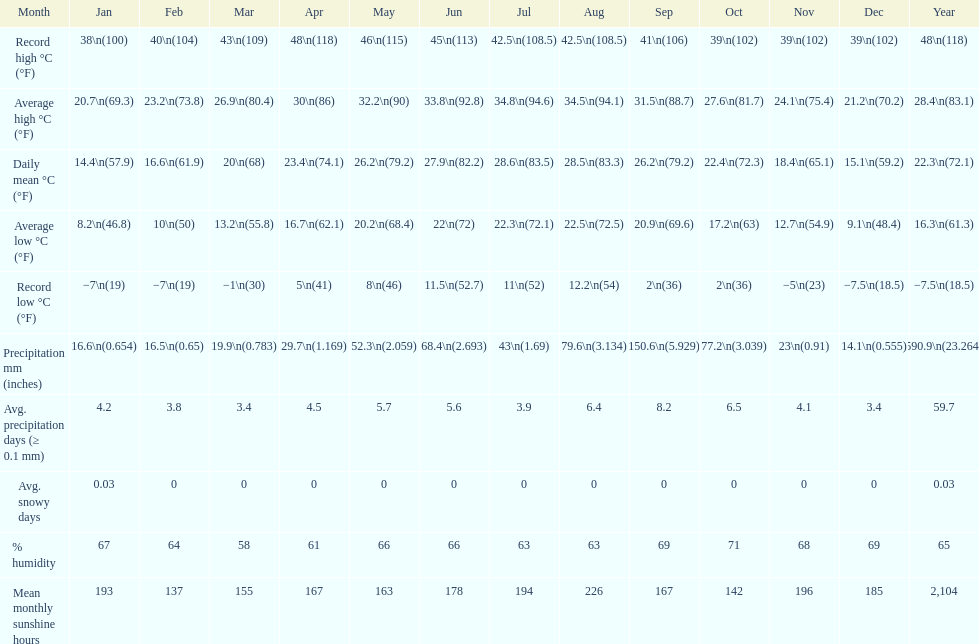Did march or april have more precipitation? April. Could you help me parse every detail presented in this table? {'header': ['Month', 'Jan', 'Feb', 'Mar', 'Apr', 'May', 'Jun', 'Jul', 'Aug', 'Sep', 'Oct', 'Nov', 'Dec', 'Year'], 'rows': [['Record high °C (°F)', '38\\n(100)', '40\\n(104)', '43\\n(109)', '48\\n(118)', '46\\n(115)', '45\\n(113)', '42.5\\n(108.5)', '42.5\\n(108.5)', '41\\n(106)', '39\\n(102)', '39\\n(102)', '39\\n(102)', '48\\n(118)'], ['Average high °C (°F)', '20.7\\n(69.3)', '23.2\\n(73.8)', '26.9\\n(80.4)', '30\\n(86)', '32.2\\n(90)', '33.8\\n(92.8)', '34.8\\n(94.6)', '34.5\\n(94.1)', '31.5\\n(88.7)', '27.6\\n(81.7)', '24.1\\n(75.4)', '21.2\\n(70.2)', '28.4\\n(83.1)'], ['Daily mean °C (°F)', '14.4\\n(57.9)', '16.6\\n(61.9)', '20\\n(68)', '23.4\\n(74.1)', '26.2\\n(79.2)', '27.9\\n(82.2)', '28.6\\n(83.5)', '28.5\\n(83.3)', '26.2\\n(79.2)', '22.4\\n(72.3)', '18.4\\n(65.1)', '15.1\\n(59.2)', '22.3\\n(72.1)'], ['Average low °C (°F)', '8.2\\n(46.8)', '10\\n(50)', '13.2\\n(55.8)', '16.7\\n(62.1)', '20.2\\n(68.4)', '22\\n(72)', '22.3\\n(72.1)', '22.5\\n(72.5)', '20.9\\n(69.6)', '17.2\\n(63)', '12.7\\n(54.9)', '9.1\\n(48.4)', '16.3\\n(61.3)'], ['Record low °C (°F)', '−7\\n(19)', '−7\\n(19)', '−1\\n(30)', '5\\n(41)', '8\\n(46)', '11.5\\n(52.7)', '11\\n(52)', '12.2\\n(54)', '2\\n(36)', '2\\n(36)', '−5\\n(23)', '−7.5\\n(18.5)', '−7.5\\n(18.5)'], ['Precipitation mm (inches)', '16.6\\n(0.654)', '16.5\\n(0.65)', '19.9\\n(0.783)', '29.7\\n(1.169)', '52.3\\n(2.059)', '68.4\\n(2.693)', '43\\n(1.69)', '79.6\\n(3.134)', '150.6\\n(5.929)', '77.2\\n(3.039)', '23\\n(0.91)', '14.1\\n(0.555)', '590.9\\n(23.264)'], ['Avg. precipitation days (≥ 0.1 mm)', '4.2', '3.8', '3.4', '4.5', '5.7', '5.6', '3.9', '6.4', '8.2', '6.5', '4.1', '3.4', '59.7'], ['Avg. snowy days', '0.03', '0', '0', '0', '0', '0', '0', '0', '0', '0', '0', '0', '0.03'], ['% humidity', '67', '64', '58', '61', '66', '66', '63', '63', '69', '71', '68', '69', '65'], ['Mean monthly sunshine hours', '193', '137', '155', '167', '163', '178', '194', '226', '167', '142', '196', '185', '2,104']]} 